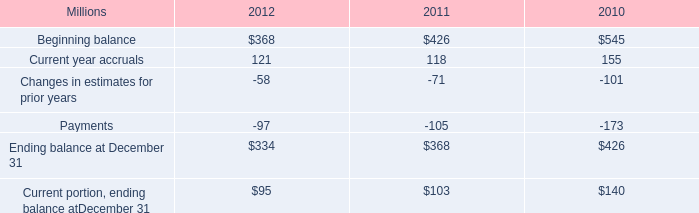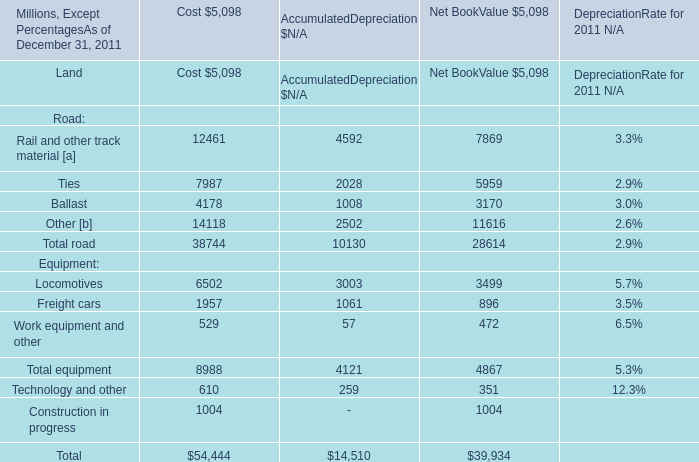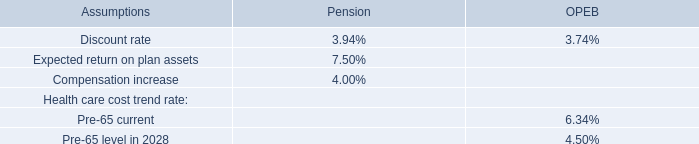What do all road sum up without those road smaller than 10000, in 2011 for cost? (in million) 
Computations: (7987 + 4178)
Answer: 12165.0. 